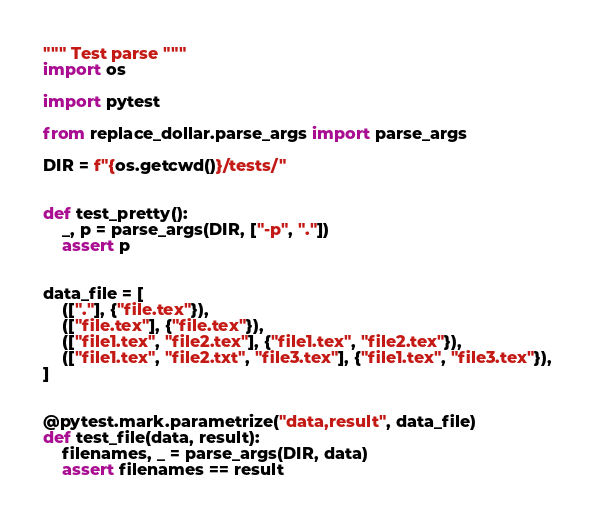<code> <loc_0><loc_0><loc_500><loc_500><_Python_>""" Test parse """
import os

import pytest

from replace_dollar.parse_args import parse_args

DIR = f"{os.getcwd()}/tests/"


def test_pretty():
    _, p = parse_args(DIR, ["-p", "."])
    assert p


data_file = [
    (["."], {"file.tex"}),
    (["file.tex"], {"file.tex"}),
    (["file1.tex", "file2.tex"], {"file1.tex", "file2.tex"}),
    (["file1.tex", "file2.txt", "file3.tex"], {"file1.tex", "file3.tex"}),
]


@pytest.mark.parametrize("data,result", data_file)
def test_file(data, result):
    filenames, _ = parse_args(DIR, data)
    assert filenames == result
</code> 